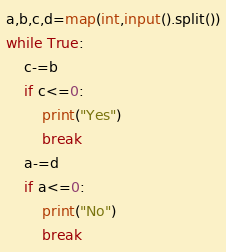<code> <loc_0><loc_0><loc_500><loc_500><_Python_>a,b,c,d=map(int,input().split())
while True:
	c-=b
	if c<=0:
		print("Yes")
		break
	a-=d
	if a<=0:
		print("No")
		break
</code> 